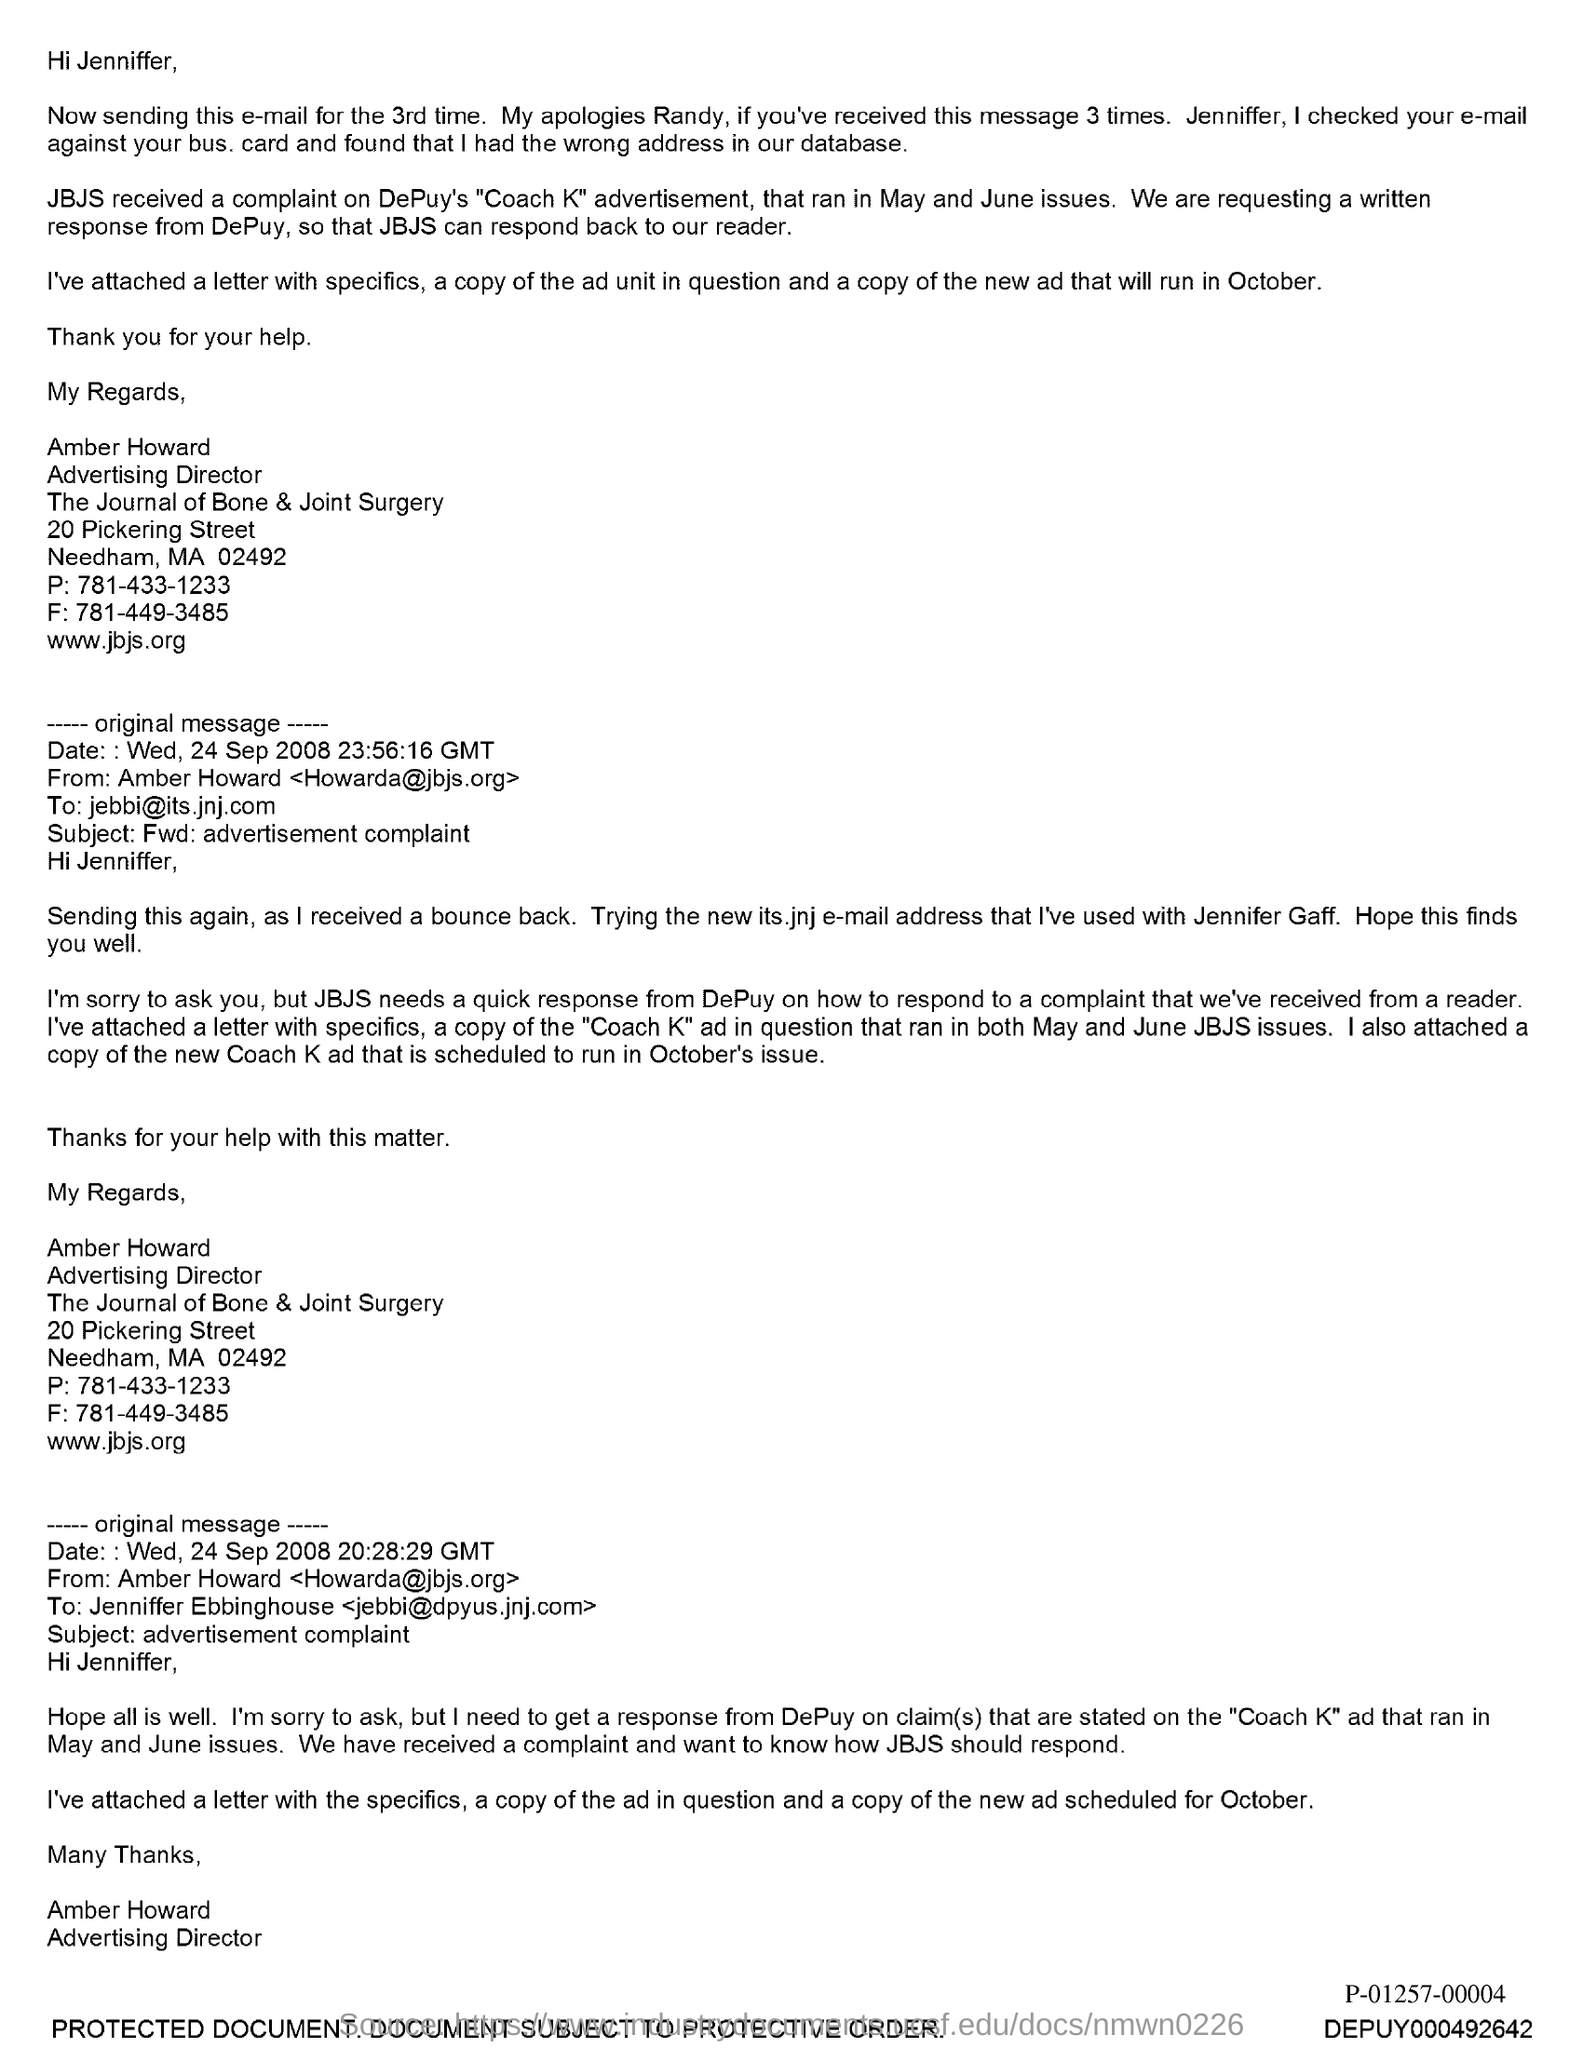Outline some significant characteristics in this image. Amber Howard holds the position of Advertising Director. 